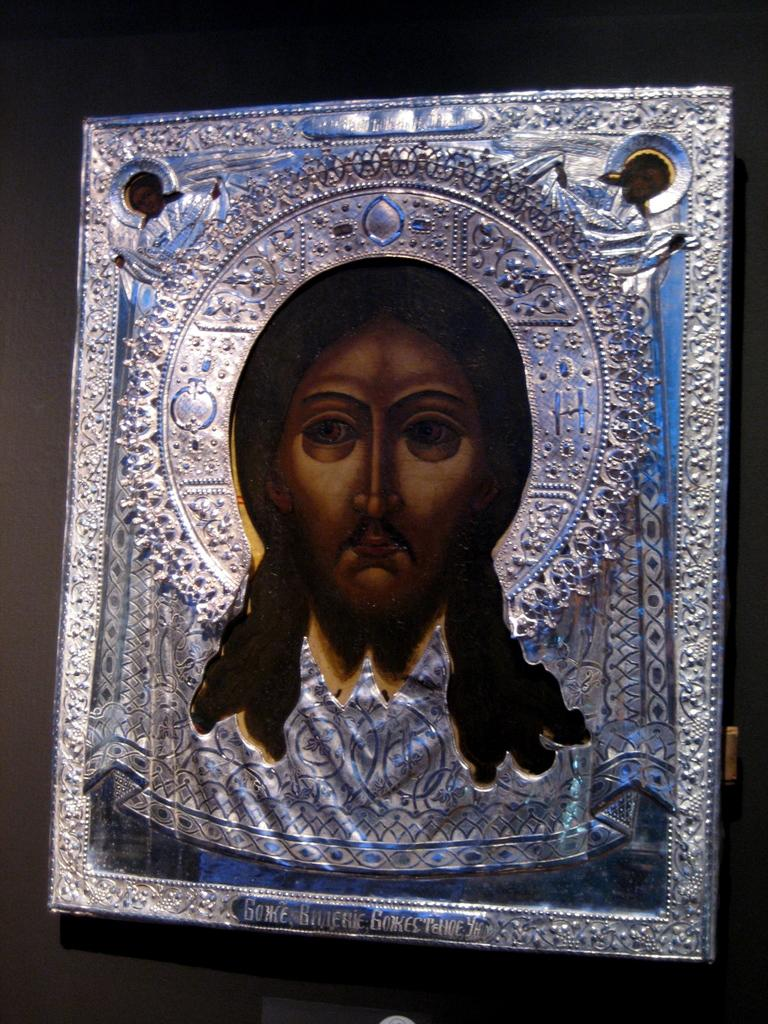What is the main object in the image? There is a frame in the image. What is depicted within the frame? The frame contains a picture of a person. Where is the frame located? The frame is on a platform. How much rice is visible in the image? There is no rice present in the image. What type of seat is shown in the image? There is no seat present in the image. 